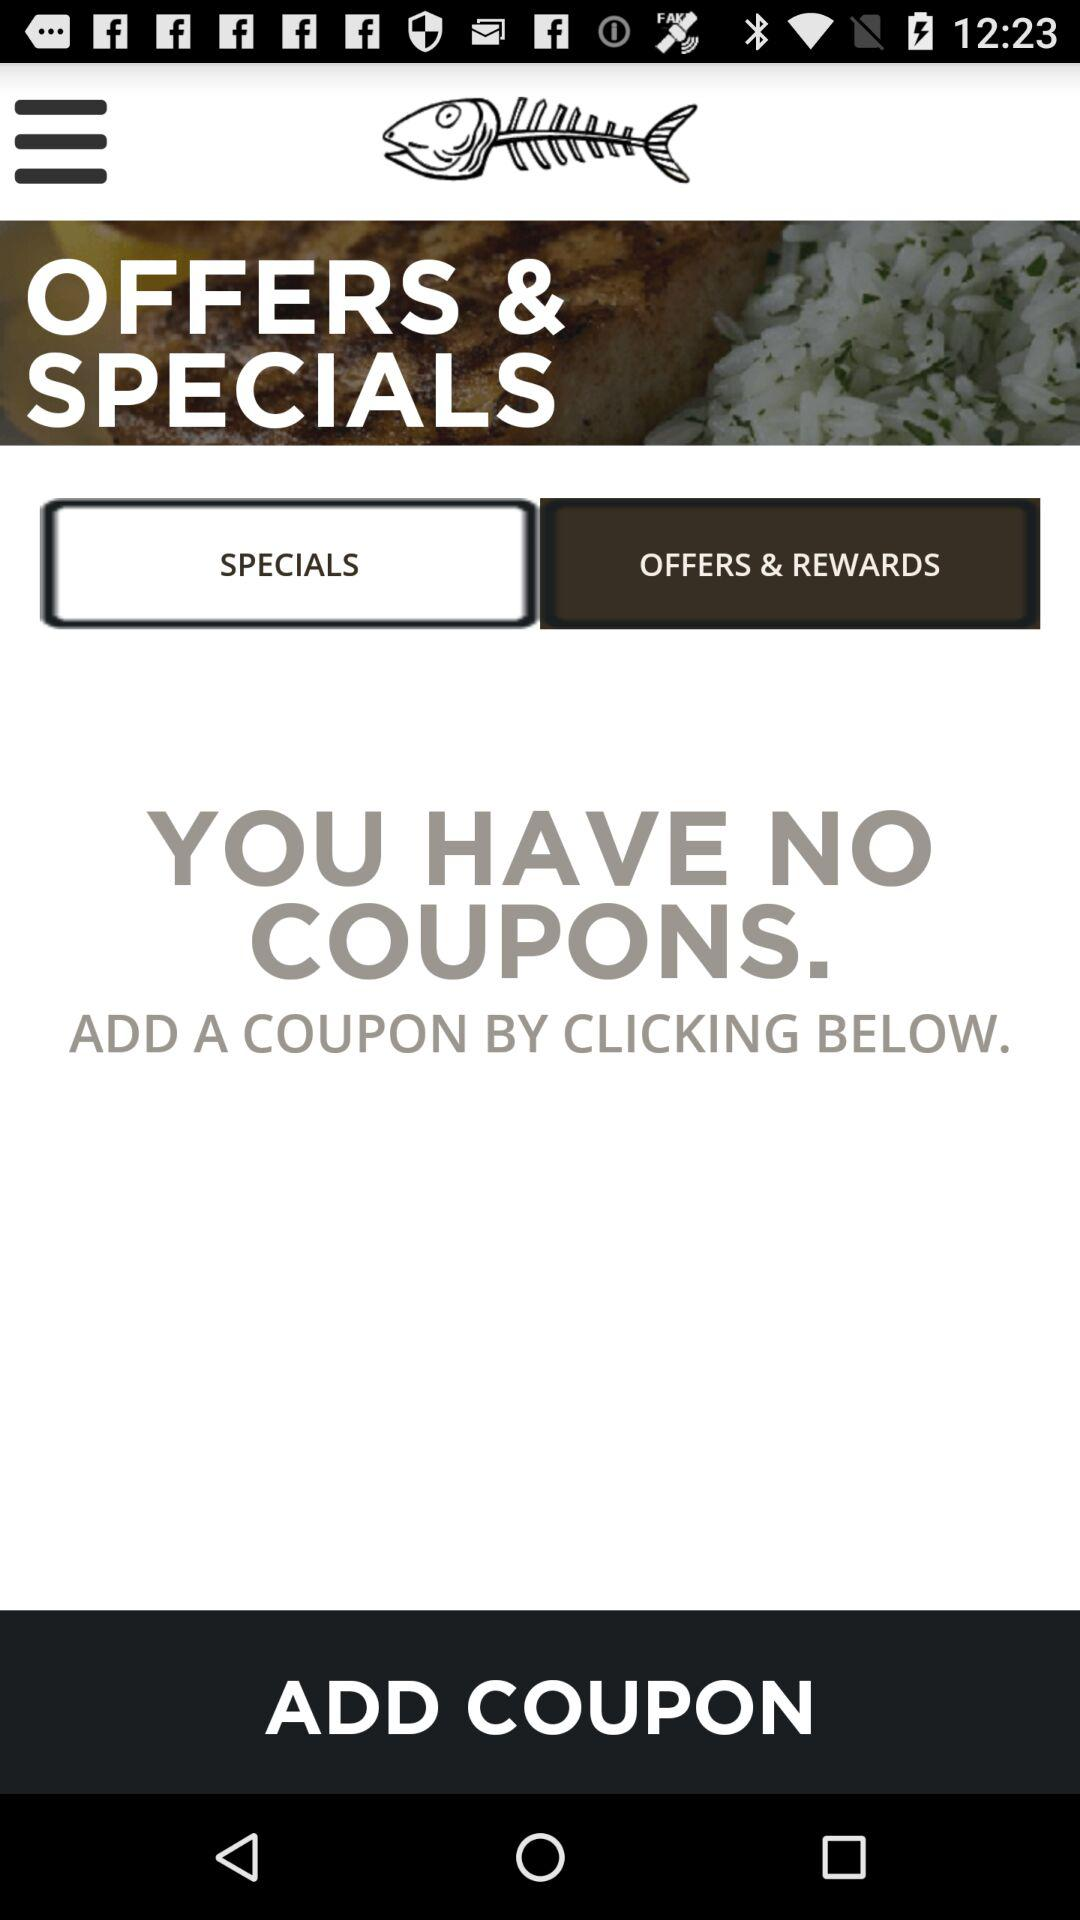How many coupons are there? There are no coupons. 